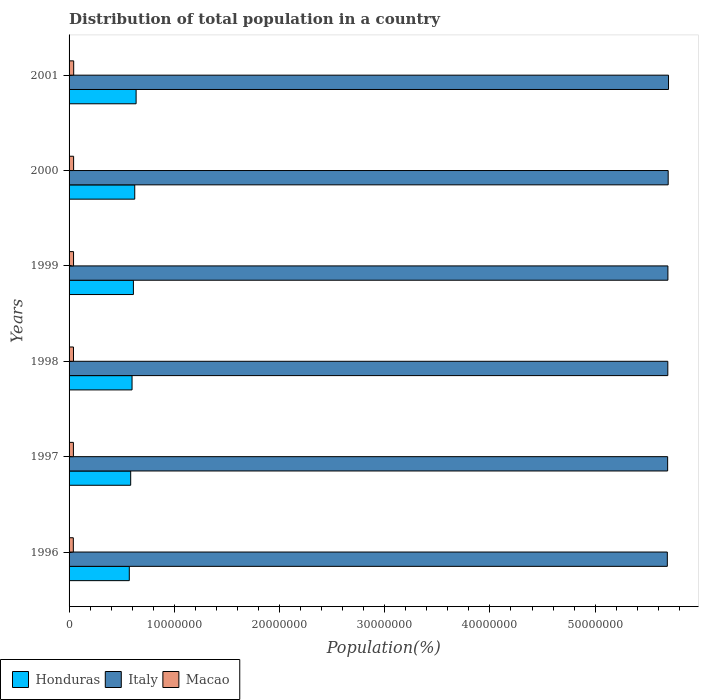How many groups of bars are there?
Provide a succinct answer. 6. Are the number of bars on each tick of the Y-axis equal?
Make the answer very short. Yes. What is the population of in Macao in 1999?
Your response must be concise. 4.25e+05. Across all years, what is the maximum population of in Macao?
Make the answer very short. 4.38e+05. Across all years, what is the minimum population of in Honduras?
Make the answer very short. 5.72e+06. In which year was the population of in Honduras maximum?
Offer a very short reply. 2001. What is the total population of in Macao in the graph?
Your answer should be compact. 2.53e+06. What is the difference between the population of in Macao in 1998 and that in 1999?
Your answer should be compact. -6638. What is the difference between the population of in Honduras in 2001 and the population of in Macao in 1999?
Your answer should be compact. 5.95e+06. What is the average population of in Italy per year?
Offer a terse response. 5.69e+07. In the year 1998, what is the difference between the population of in Macao and population of in Italy?
Make the answer very short. -5.65e+07. What is the ratio of the population of in Macao in 1997 to that in 2000?
Provide a succinct answer. 0.95. Is the population of in Honduras in 1997 less than that in 2000?
Keep it short and to the point. Yes. Is the difference between the population of in Macao in 1998 and 1999 greater than the difference between the population of in Italy in 1998 and 1999?
Your answer should be very brief. Yes. What is the difference between the highest and the second highest population of in Macao?
Provide a short and direct response. 6181. What is the difference between the highest and the lowest population of in Italy?
Keep it short and to the point. 1.14e+05. In how many years, is the population of in Italy greater than the average population of in Italy taken over all years?
Your answer should be compact. 3. What does the 1st bar from the top in 2000 represents?
Keep it short and to the point. Macao. What does the 1st bar from the bottom in 1996 represents?
Give a very brief answer. Honduras. How many bars are there?
Ensure brevity in your answer.  18. Are all the bars in the graph horizontal?
Your answer should be compact. Yes. How many years are there in the graph?
Offer a terse response. 6. What is the difference between two consecutive major ticks on the X-axis?
Provide a short and direct response. 1.00e+07. Where does the legend appear in the graph?
Provide a short and direct response. Bottom left. How many legend labels are there?
Keep it short and to the point. 3. What is the title of the graph?
Give a very brief answer. Distribution of total population in a country. What is the label or title of the X-axis?
Provide a succinct answer. Population(%). What is the label or title of the Y-axis?
Keep it short and to the point. Years. What is the Population(%) in Honduras in 1996?
Offer a very short reply. 5.72e+06. What is the Population(%) of Italy in 1996?
Provide a short and direct response. 5.69e+07. What is the Population(%) of Macao in 1996?
Make the answer very short. 4.05e+05. What is the Population(%) in Honduras in 1997?
Your answer should be compact. 5.86e+06. What is the Population(%) of Italy in 1997?
Offer a very short reply. 5.69e+07. What is the Population(%) of Macao in 1997?
Make the answer very short. 4.12e+05. What is the Population(%) in Honduras in 1998?
Provide a succinct answer. 5.99e+06. What is the Population(%) of Italy in 1998?
Offer a very short reply. 5.69e+07. What is the Population(%) in Macao in 1998?
Your response must be concise. 4.19e+05. What is the Population(%) in Honduras in 1999?
Offer a terse response. 6.11e+06. What is the Population(%) in Italy in 1999?
Offer a terse response. 5.69e+07. What is the Population(%) in Macao in 1999?
Provide a succinct answer. 4.25e+05. What is the Population(%) in Honduras in 2000?
Provide a succinct answer. 6.24e+06. What is the Population(%) in Italy in 2000?
Ensure brevity in your answer.  5.69e+07. What is the Population(%) in Macao in 2000?
Provide a short and direct response. 4.32e+05. What is the Population(%) in Honduras in 2001?
Ensure brevity in your answer.  6.37e+06. What is the Population(%) of Italy in 2001?
Offer a terse response. 5.70e+07. What is the Population(%) of Macao in 2001?
Offer a terse response. 4.38e+05. Across all years, what is the maximum Population(%) in Honduras?
Your answer should be very brief. 6.37e+06. Across all years, what is the maximum Population(%) of Italy?
Provide a succinct answer. 5.70e+07. Across all years, what is the maximum Population(%) of Macao?
Offer a terse response. 4.38e+05. Across all years, what is the minimum Population(%) in Honduras?
Provide a short and direct response. 5.72e+06. Across all years, what is the minimum Population(%) of Italy?
Offer a very short reply. 5.69e+07. Across all years, what is the minimum Population(%) in Macao?
Ensure brevity in your answer.  4.05e+05. What is the total Population(%) of Honduras in the graph?
Make the answer very short. 3.63e+07. What is the total Population(%) of Italy in the graph?
Provide a succinct answer. 3.41e+08. What is the total Population(%) of Macao in the graph?
Your answer should be very brief. 2.53e+06. What is the difference between the Population(%) of Honduras in 1996 and that in 1997?
Offer a terse response. -1.31e+05. What is the difference between the Population(%) of Italy in 1996 and that in 1997?
Make the answer very short. -3.01e+04. What is the difference between the Population(%) in Macao in 1996 and that in 1997?
Offer a terse response. -6800. What is the difference between the Population(%) in Honduras in 1996 and that in 1998?
Your response must be concise. -2.61e+05. What is the difference between the Population(%) of Italy in 1996 and that in 1998?
Keep it short and to the point. -4.65e+04. What is the difference between the Population(%) in Macao in 1996 and that in 1998?
Make the answer very short. -1.36e+04. What is the difference between the Population(%) in Honduras in 1996 and that in 1999?
Give a very brief answer. -3.90e+05. What is the difference between the Population(%) in Italy in 1996 and that in 1999?
Keep it short and to the point. -5.60e+04. What is the difference between the Population(%) in Macao in 1996 and that in 1999?
Ensure brevity in your answer.  -2.02e+04. What is the difference between the Population(%) in Honduras in 1996 and that in 2000?
Provide a short and direct response. -5.18e+05. What is the difference between the Population(%) of Italy in 1996 and that in 2000?
Offer a terse response. -8.18e+04. What is the difference between the Population(%) in Macao in 1996 and that in 2000?
Your answer should be compact. -2.67e+04. What is the difference between the Population(%) of Honduras in 1996 and that in 2001?
Your answer should be compact. -6.47e+05. What is the difference between the Population(%) in Italy in 1996 and that in 2001?
Keep it short and to the point. -1.14e+05. What is the difference between the Population(%) of Macao in 1996 and that in 2001?
Provide a short and direct response. -3.29e+04. What is the difference between the Population(%) of Honduras in 1997 and that in 1998?
Make the answer very short. -1.30e+05. What is the difference between the Population(%) in Italy in 1997 and that in 1998?
Make the answer very short. -1.64e+04. What is the difference between the Population(%) in Macao in 1997 and that in 1998?
Your answer should be compact. -6779. What is the difference between the Population(%) in Honduras in 1997 and that in 1999?
Your answer should be very brief. -2.59e+05. What is the difference between the Population(%) in Italy in 1997 and that in 1999?
Offer a very short reply. -2.59e+04. What is the difference between the Population(%) in Macao in 1997 and that in 1999?
Make the answer very short. -1.34e+04. What is the difference between the Population(%) in Honduras in 1997 and that in 2000?
Make the answer very short. -3.87e+05. What is the difference between the Population(%) in Italy in 1997 and that in 2000?
Make the answer very short. -5.17e+04. What is the difference between the Population(%) of Macao in 1997 and that in 2000?
Keep it short and to the point. -1.99e+04. What is the difference between the Population(%) of Honduras in 1997 and that in 2001?
Your answer should be compact. -5.15e+05. What is the difference between the Population(%) in Italy in 1997 and that in 2001?
Your answer should be compact. -8.37e+04. What is the difference between the Population(%) of Macao in 1997 and that in 2001?
Your answer should be very brief. -2.61e+04. What is the difference between the Population(%) of Honduras in 1998 and that in 1999?
Keep it short and to the point. -1.29e+05. What is the difference between the Population(%) in Italy in 1998 and that in 1999?
Your answer should be compact. -9573. What is the difference between the Population(%) of Macao in 1998 and that in 1999?
Provide a succinct answer. -6638. What is the difference between the Population(%) of Honduras in 1998 and that in 2000?
Your answer should be compact. -2.57e+05. What is the difference between the Population(%) of Italy in 1998 and that in 2000?
Make the answer very short. -3.54e+04. What is the difference between the Population(%) of Macao in 1998 and that in 2000?
Keep it short and to the point. -1.31e+04. What is the difference between the Population(%) in Honduras in 1998 and that in 2001?
Your response must be concise. -3.86e+05. What is the difference between the Population(%) of Italy in 1998 and that in 2001?
Give a very brief answer. -6.74e+04. What is the difference between the Population(%) in Macao in 1998 and that in 2001?
Make the answer very short. -1.93e+04. What is the difference between the Population(%) in Honduras in 1999 and that in 2000?
Offer a very short reply. -1.29e+05. What is the difference between the Population(%) of Italy in 1999 and that in 2000?
Offer a terse response. -2.58e+04. What is the difference between the Population(%) of Macao in 1999 and that in 2000?
Give a very brief answer. -6459. What is the difference between the Population(%) of Honduras in 1999 and that in 2001?
Your response must be concise. -2.57e+05. What is the difference between the Population(%) in Italy in 1999 and that in 2001?
Your answer should be very brief. -5.78e+04. What is the difference between the Population(%) of Macao in 1999 and that in 2001?
Provide a short and direct response. -1.26e+04. What is the difference between the Population(%) in Honduras in 2000 and that in 2001?
Offer a terse response. -1.28e+05. What is the difference between the Population(%) in Italy in 2000 and that in 2001?
Ensure brevity in your answer.  -3.20e+04. What is the difference between the Population(%) in Macao in 2000 and that in 2001?
Keep it short and to the point. -6181. What is the difference between the Population(%) in Honduras in 1996 and the Population(%) in Italy in 1997?
Your response must be concise. -5.12e+07. What is the difference between the Population(%) in Honduras in 1996 and the Population(%) in Macao in 1997?
Provide a succinct answer. 5.31e+06. What is the difference between the Population(%) in Italy in 1996 and the Population(%) in Macao in 1997?
Your response must be concise. 5.64e+07. What is the difference between the Population(%) of Honduras in 1996 and the Population(%) of Italy in 1998?
Offer a very short reply. -5.12e+07. What is the difference between the Population(%) in Honduras in 1996 and the Population(%) in Macao in 1998?
Give a very brief answer. 5.31e+06. What is the difference between the Population(%) of Italy in 1996 and the Population(%) of Macao in 1998?
Make the answer very short. 5.64e+07. What is the difference between the Population(%) in Honduras in 1996 and the Population(%) in Italy in 1999?
Give a very brief answer. -5.12e+07. What is the difference between the Population(%) in Honduras in 1996 and the Population(%) in Macao in 1999?
Offer a very short reply. 5.30e+06. What is the difference between the Population(%) of Italy in 1996 and the Population(%) of Macao in 1999?
Offer a terse response. 5.64e+07. What is the difference between the Population(%) in Honduras in 1996 and the Population(%) in Italy in 2000?
Provide a short and direct response. -5.12e+07. What is the difference between the Population(%) of Honduras in 1996 and the Population(%) of Macao in 2000?
Keep it short and to the point. 5.29e+06. What is the difference between the Population(%) of Italy in 1996 and the Population(%) of Macao in 2000?
Your response must be concise. 5.64e+07. What is the difference between the Population(%) of Honduras in 1996 and the Population(%) of Italy in 2001?
Your response must be concise. -5.12e+07. What is the difference between the Population(%) in Honduras in 1996 and the Population(%) in Macao in 2001?
Your response must be concise. 5.29e+06. What is the difference between the Population(%) of Italy in 1996 and the Population(%) of Macao in 2001?
Your answer should be compact. 5.64e+07. What is the difference between the Population(%) of Honduras in 1997 and the Population(%) of Italy in 1998?
Provide a short and direct response. -5.11e+07. What is the difference between the Population(%) in Honduras in 1997 and the Population(%) in Macao in 1998?
Your response must be concise. 5.44e+06. What is the difference between the Population(%) in Italy in 1997 and the Population(%) in Macao in 1998?
Your answer should be compact. 5.65e+07. What is the difference between the Population(%) in Honduras in 1997 and the Population(%) in Italy in 1999?
Your response must be concise. -5.11e+07. What is the difference between the Population(%) in Honduras in 1997 and the Population(%) in Macao in 1999?
Your answer should be compact. 5.43e+06. What is the difference between the Population(%) of Italy in 1997 and the Population(%) of Macao in 1999?
Provide a short and direct response. 5.65e+07. What is the difference between the Population(%) in Honduras in 1997 and the Population(%) in Italy in 2000?
Provide a short and direct response. -5.11e+07. What is the difference between the Population(%) of Honduras in 1997 and the Population(%) of Macao in 2000?
Provide a short and direct response. 5.42e+06. What is the difference between the Population(%) of Italy in 1997 and the Population(%) of Macao in 2000?
Offer a very short reply. 5.65e+07. What is the difference between the Population(%) of Honduras in 1997 and the Population(%) of Italy in 2001?
Your answer should be very brief. -5.11e+07. What is the difference between the Population(%) in Honduras in 1997 and the Population(%) in Macao in 2001?
Keep it short and to the point. 5.42e+06. What is the difference between the Population(%) of Italy in 1997 and the Population(%) of Macao in 2001?
Ensure brevity in your answer.  5.65e+07. What is the difference between the Population(%) of Honduras in 1998 and the Population(%) of Italy in 1999?
Your response must be concise. -5.09e+07. What is the difference between the Population(%) in Honduras in 1998 and the Population(%) in Macao in 1999?
Offer a terse response. 5.56e+06. What is the difference between the Population(%) of Italy in 1998 and the Population(%) of Macao in 1999?
Give a very brief answer. 5.65e+07. What is the difference between the Population(%) of Honduras in 1998 and the Population(%) of Italy in 2000?
Keep it short and to the point. -5.10e+07. What is the difference between the Population(%) in Honduras in 1998 and the Population(%) in Macao in 2000?
Your answer should be compact. 5.55e+06. What is the difference between the Population(%) of Italy in 1998 and the Population(%) of Macao in 2000?
Make the answer very short. 5.65e+07. What is the difference between the Population(%) in Honduras in 1998 and the Population(%) in Italy in 2001?
Provide a succinct answer. -5.10e+07. What is the difference between the Population(%) in Honduras in 1998 and the Population(%) in Macao in 2001?
Offer a very short reply. 5.55e+06. What is the difference between the Population(%) of Italy in 1998 and the Population(%) of Macao in 2001?
Your answer should be very brief. 5.65e+07. What is the difference between the Population(%) of Honduras in 1999 and the Population(%) of Italy in 2000?
Give a very brief answer. -5.08e+07. What is the difference between the Population(%) in Honduras in 1999 and the Population(%) in Macao in 2000?
Your response must be concise. 5.68e+06. What is the difference between the Population(%) of Italy in 1999 and the Population(%) of Macao in 2000?
Offer a terse response. 5.65e+07. What is the difference between the Population(%) of Honduras in 1999 and the Population(%) of Italy in 2001?
Offer a very short reply. -5.09e+07. What is the difference between the Population(%) in Honduras in 1999 and the Population(%) in Macao in 2001?
Make the answer very short. 5.68e+06. What is the difference between the Population(%) in Italy in 1999 and the Population(%) in Macao in 2001?
Offer a very short reply. 5.65e+07. What is the difference between the Population(%) in Honduras in 2000 and the Population(%) in Italy in 2001?
Your answer should be compact. -5.07e+07. What is the difference between the Population(%) in Honduras in 2000 and the Population(%) in Macao in 2001?
Give a very brief answer. 5.80e+06. What is the difference between the Population(%) of Italy in 2000 and the Population(%) of Macao in 2001?
Make the answer very short. 5.65e+07. What is the average Population(%) in Honduras per year?
Offer a terse response. 6.05e+06. What is the average Population(%) of Italy per year?
Offer a terse response. 5.69e+07. What is the average Population(%) in Macao per year?
Your answer should be compact. 4.22e+05. In the year 1996, what is the difference between the Population(%) of Honduras and Population(%) of Italy?
Give a very brief answer. -5.11e+07. In the year 1996, what is the difference between the Population(%) in Honduras and Population(%) in Macao?
Offer a terse response. 5.32e+06. In the year 1996, what is the difference between the Population(%) of Italy and Population(%) of Macao?
Offer a terse response. 5.65e+07. In the year 1997, what is the difference between the Population(%) of Honduras and Population(%) of Italy?
Provide a succinct answer. -5.10e+07. In the year 1997, what is the difference between the Population(%) of Honduras and Population(%) of Macao?
Your answer should be compact. 5.44e+06. In the year 1997, what is the difference between the Population(%) of Italy and Population(%) of Macao?
Provide a succinct answer. 5.65e+07. In the year 1998, what is the difference between the Population(%) of Honduras and Population(%) of Italy?
Your answer should be very brief. -5.09e+07. In the year 1998, what is the difference between the Population(%) in Honduras and Population(%) in Macao?
Make the answer very short. 5.57e+06. In the year 1998, what is the difference between the Population(%) in Italy and Population(%) in Macao?
Keep it short and to the point. 5.65e+07. In the year 1999, what is the difference between the Population(%) in Honduras and Population(%) in Italy?
Your answer should be very brief. -5.08e+07. In the year 1999, what is the difference between the Population(%) of Honduras and Population(%) of Macao?
Your answer should be very brief. 5.69e+06. In the year 1999, what is the difference between the Population(%) in Italy and Population(%) in Macao?
Give a very brief answer. 5.65e+07. In the year 2000, what is the difference between the Population(%) of Honduras and Population(%) of Italy?
Offer a very short reply. -5.07e+07. In the year 2000, what is the difference between the Population(%) of Honduras and Population(%) of Macao?
Offer a very short reply. 5.81e+06. In the year 2000, what is the difference between the Population(%) in Italy and Population(%) in Macao?
Ensure brevity in your answer.  5.65e+07. In the year 2001, what is the difference between the Population(%) of Honduras and Population(%) of Italy?
Keep it short and to the point. -5.06e+07. In the year 2001, what is the difference between the Population(%) in Honduras and Population(%) in Macao?
Your answer should be compact. 5.93e+06. In the year 2001, what is the difference between the Population(%) in Italy and Population(%) in Macao?
Ensure brevity in your answer.  5.65e+07. What is the ratio of the Population(%) of Honduras in 1996 to that in 1997?
Make the answer very short. 0.98. What is the ratio of the Population(%) in Macao in 1996 to that in 1997?
Ensure brevity in your answer.  0.98. What is the ratio of the Population(%) of Honduras in 1996 to that in 1998?
Your answer should be very brief. 0.96. What is the ratio of the Population(%) in Italy in 1996 to that in 1998?
Offer a terse response. 1. What is the ratio of the Population(%) in Macao in 1996 to that in 1998?
Make the answer very short. 0.97. What is the ratio of the Population(%) of Honduras in 1996 to that in 1999?
Offer a terse response. 0.94. What is the ratio of the Population(%) in Italy in 1996 to that in 1999?
Ensure brevity in your answer.  1. What is the ratio of the Population(%) of Macao in 1996 to that in 1999?
Provide a succinct answer. 0.95. What is the ratio of the Population(%) of Honduras in 1996 to that in 2000?
Provide a succinct answer. 0.92. What is the ratio of the Population(%) in Macao in 1996 to that in 2000?
Offer a terse response. 0.94. What is the ratio of the Population(%) in Honduras in 1996 to that in 2001?
Give a very brief answer. 0.9. What is the ratio of the Population(%) in Macao in 1996 to that in 2001?
Offer a very short reply. 0.93. What is the ratio of the Population(%) in Honduras in 1997 to that in 1998?
Provide a short and direct response. 0.98. What is the ratio of the Population(%) in Macao in 1997 to that in 1998?
Provide a succinct answer. 0.98. What is the ratio of the Population(%) of Honduras in 1997 to that in 1999?
Your response must be concise. 0.96. What is the ratio of the Population(%) in Macao in 1997 to that in 1999?
Your answer should be very brief. 0.97. What is the ratio of the Population(%) in Honduras in 1997 to that in 2000?
Your answer should be compact. 0.94. What is the ratio of the Population(%) of Italy in 1997 to that in 2000?
Ensure brevity in your answer.  1. What is the ratio of the Population(%) of Macao in 1997 to that in 2000?
Provide a short and direct response. 0.95. What is the ratio of the Population(%) in Honduras in 1997 to that in 2001?
Keep it short and to the point. 0.92. What is the ratio of the Population(%) in Macao in 1997 to that in 2001?
Offer a terse response. 0.94. What is the ratio of the Population(%) in Honduras in 1998 to that in 1999?
Offer a very short reply. 0.98. What is the ratio of the Population(%) of Italy in 1998 to that in 1999?
Your response must be concise. 1. What is the ratio of the Population(%) of Macao in 1998 to that in 1999?
Keep it short and to the point. 0.98. What is the ratio of the Population(%) of Honduras in 1998 to that in 2000?
Keep it short and to the point. 0.96. What is the ratio of the Population(%) in Macao in 1998 to that in 2000?
Offer a very short reply. 0.97. What is the ratio of the Population(%) of Honduras in 1998 to that in 2001?
Provide a succinct answer. 0.94. What is the ratio of the Population(%) in Macao in 1998 to that in 2001?
Your answer should be compact. 0.96. What is the ratio of the Population(%) in Honduras in 1999 to that in 2000?
Give a very brief answer. 0.98. What is the ratio of the Population(%) in Honduras in 1999 to that in 2001?
Provide a succinct answer. 0.96. What is the ratio of the Population(%) of Macao in 1999 to that in 2001?
Give a very brief answer. 0.97. What is the ratio of the Population(%) of Honduras in 2000 to that in 2001?
Keep it short and to the point. 0.98. What is the ratio of the Population(%) in Macao in 2000 to that in 2001?
Your response must be concise. 0.99. What is the difference between the highest and the second highest Population(%) in Honduras?
Ensure brevity in your answer.  1.28e+05. What is the difference between the highest and the second highest Population(%) of Italy?
Keep it short and to the point. 3.20e+04. What is the difference between the highest and the second highest Population(%) of Macao?
Your answer should be very brief. 6181. What is the difference between the highest and the lowest Population(%) of Honduras?
Give a very brief answer. 6.47e+05. What is the difference between the highest and the lowest Population(%) of Italy?
Your answer should be very brief. 1.14e+05. What is the difference between the highest and the lowest Population(%) of Macao?
Offer a terse response. 3.29e+04. 